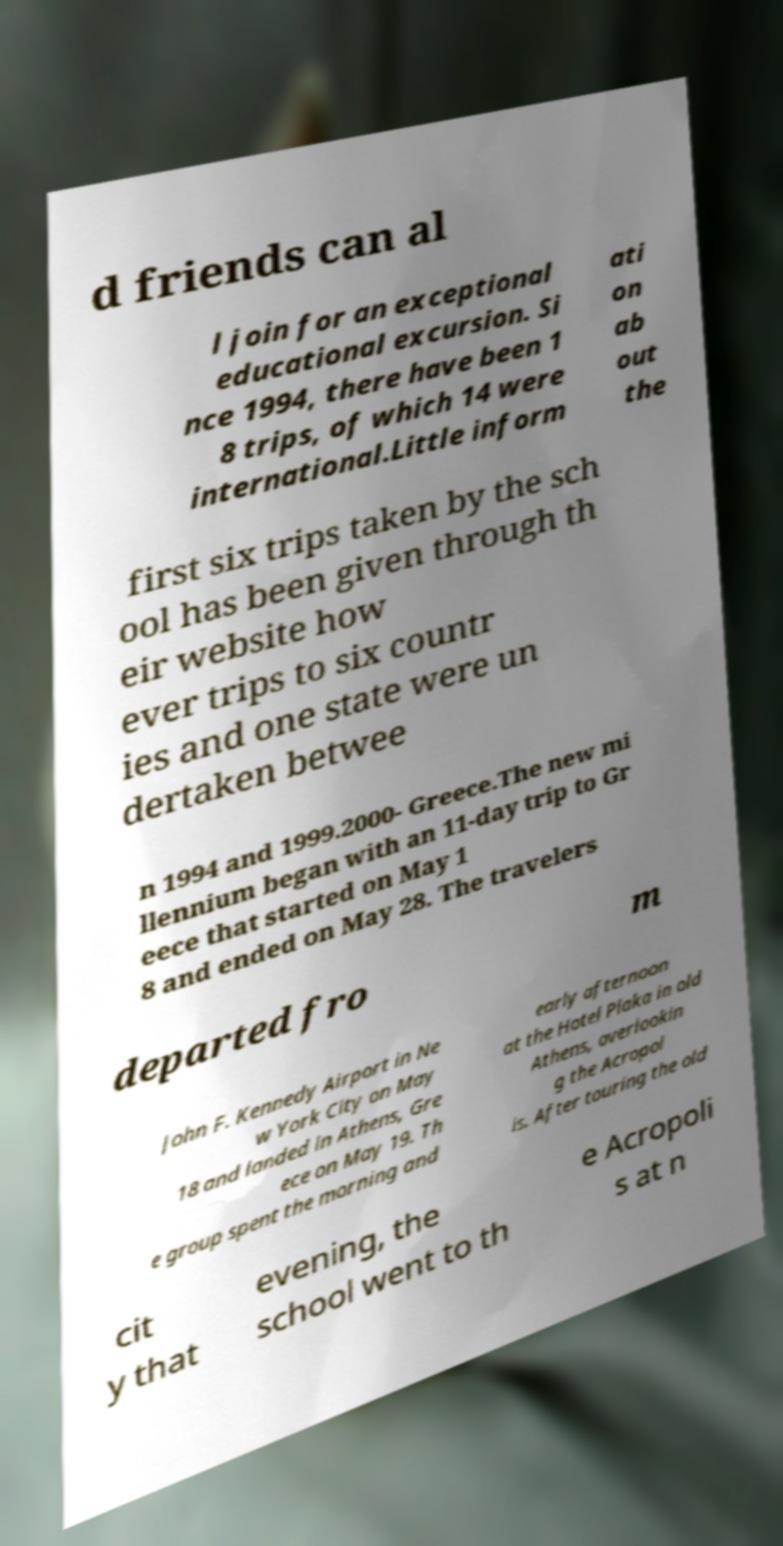I need the written content from this picture converted into text. Can you do that? d friends can al l join for an exceptional educational excursion. Si nce 1994, there have been 1 8 trips, of which 14 were international.Little inform ati on ab out the first six trips taken by the sch ool has been given through th eir website how ever trips to six countr ies and one state were un dertaken betwee n 1994 and 1999.2000- Greece.The new mi llennium began with an 11-day trip to Gr eece that started on May 1 8 and ended on May 28. The travelers departed fro m John F. Kennedy Airport in Ne w York City on May 18 and landed in Athens, Gre ece on May 19. Th e group spent the morning and early afternoon at the Hotel Plaka in old Athens, overlookin g the Acropol is. After touring the old cit y that evening, the school went to th e Acropoli s at n 